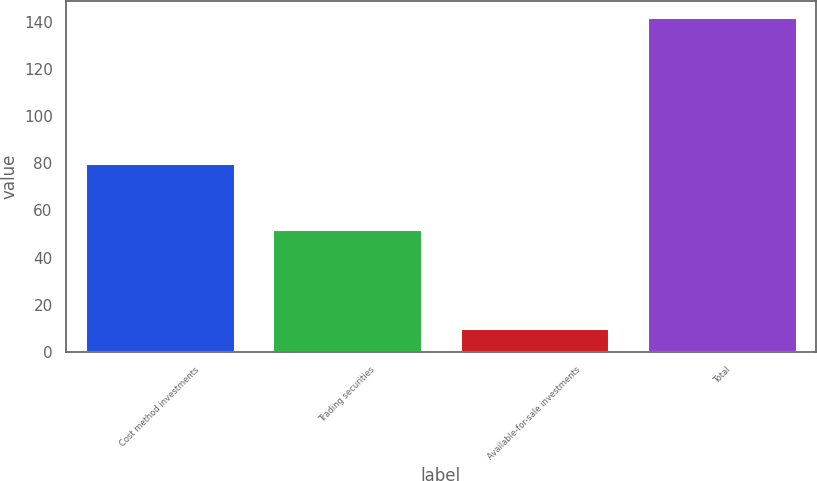Convert chart. <chart><loc_0><loc_0><loc_500><loc_500><bar_chart><fcel>Cost method investments<fcel>Trading securities<fcel>Available-for-sale investments<fcel>Total<nl><fcel>80<fcel>52<fcel>10<fcel>142<nl></chart> 